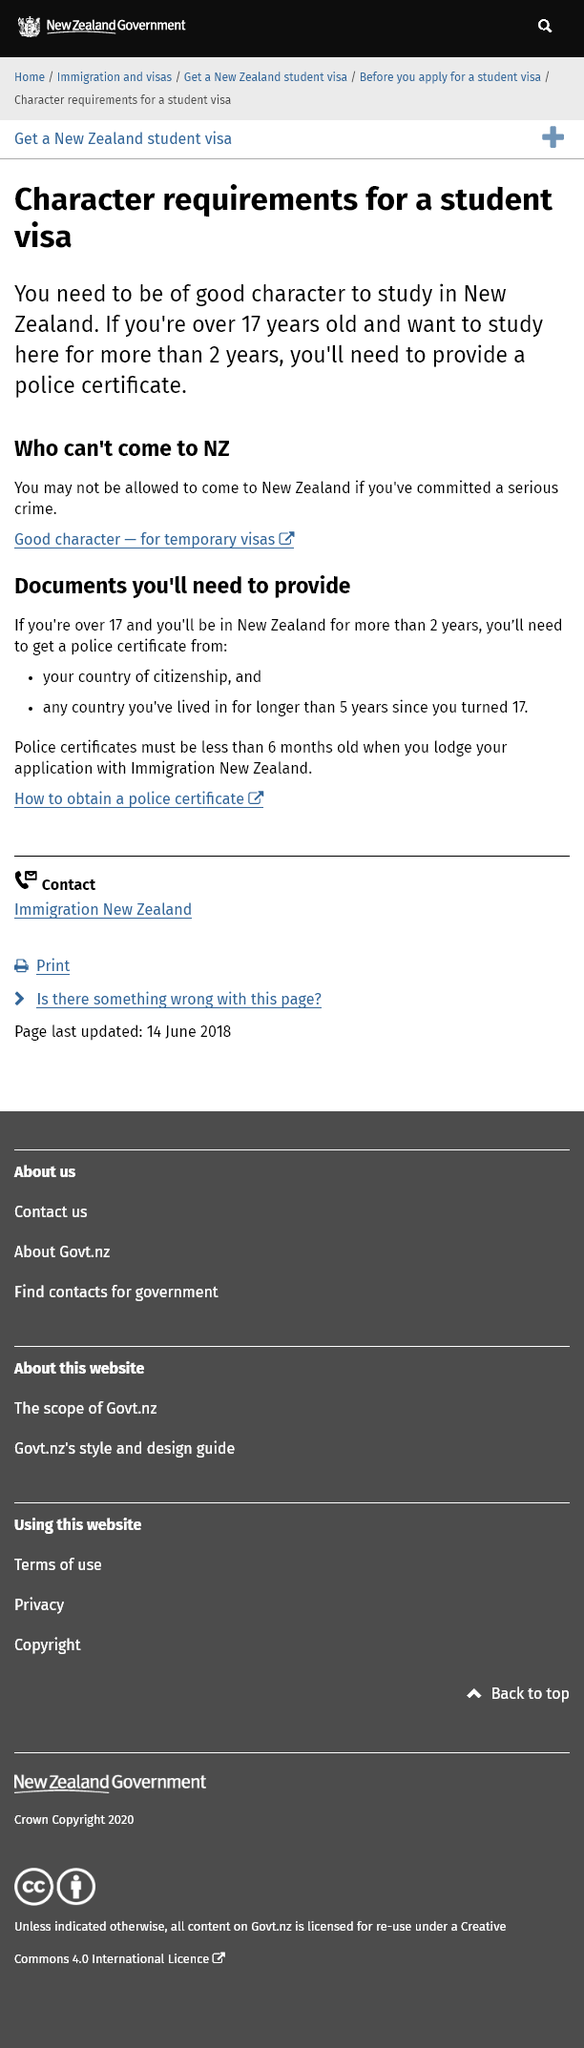Point out several critical features in this image. Police certificates must be less than 6 months old when applying. It is necessary to provide a police certificate in order to obtain certain documents. Anyone who has committed a serious crime is prohibited from entering New Zealand. 